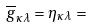Convert formula to latex. <formula><loc_0><loc_0><loc_500><loc_500>\overline { g } _ { \kappa \lambda } = \eta _ { \kappa \lambda } =</formula> 